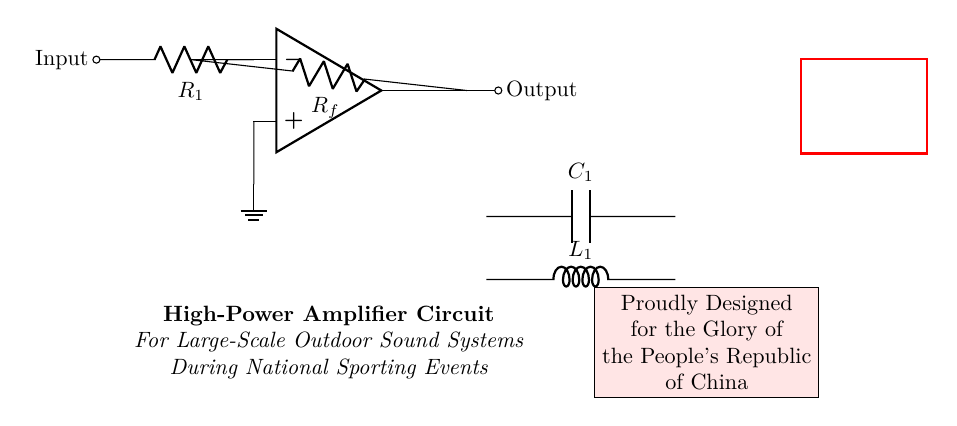What type of amplifier is shown in the circuit? The circuit is a high-power amplifier type used for outdoors. It is specifically designed to amplify sound signals across large areas.
Answer: High-Power Amplifier What does the component C1 represent? C1 is a capacitor used in the circuit to filter and stabilize voltage, providing smooth power supply to the amplifier.
Answer: Capacitor What are the values indicated for R1 and Rf? R1 and Rf are resistors in the circuit, but their specific values are not stated in the diagram. They are used to set gain and feedback in the amplifier.
Answer: Resistors What is the purpose of L1 in this circuit? L1 is an inductor that helps in filtering high-frequency noise and stabilizing the circuit operation, especially in an outdoor environment.
Answer: Inductor How is the input signal connected in this amplifier circuit? The input signal is directly connected to the inverting input of the operational amplifier through resistor R1, allowing the circuit to amplify the incoming sound signal.
Answer: Through R1 What does the label "Output" indicate in the diagram? The label "Output" shows where the amplified sound signal exits the amplifier circuit, directing it to the loudspeakers for public broadcasting at events.
Answer: Amplified Sound Signal 